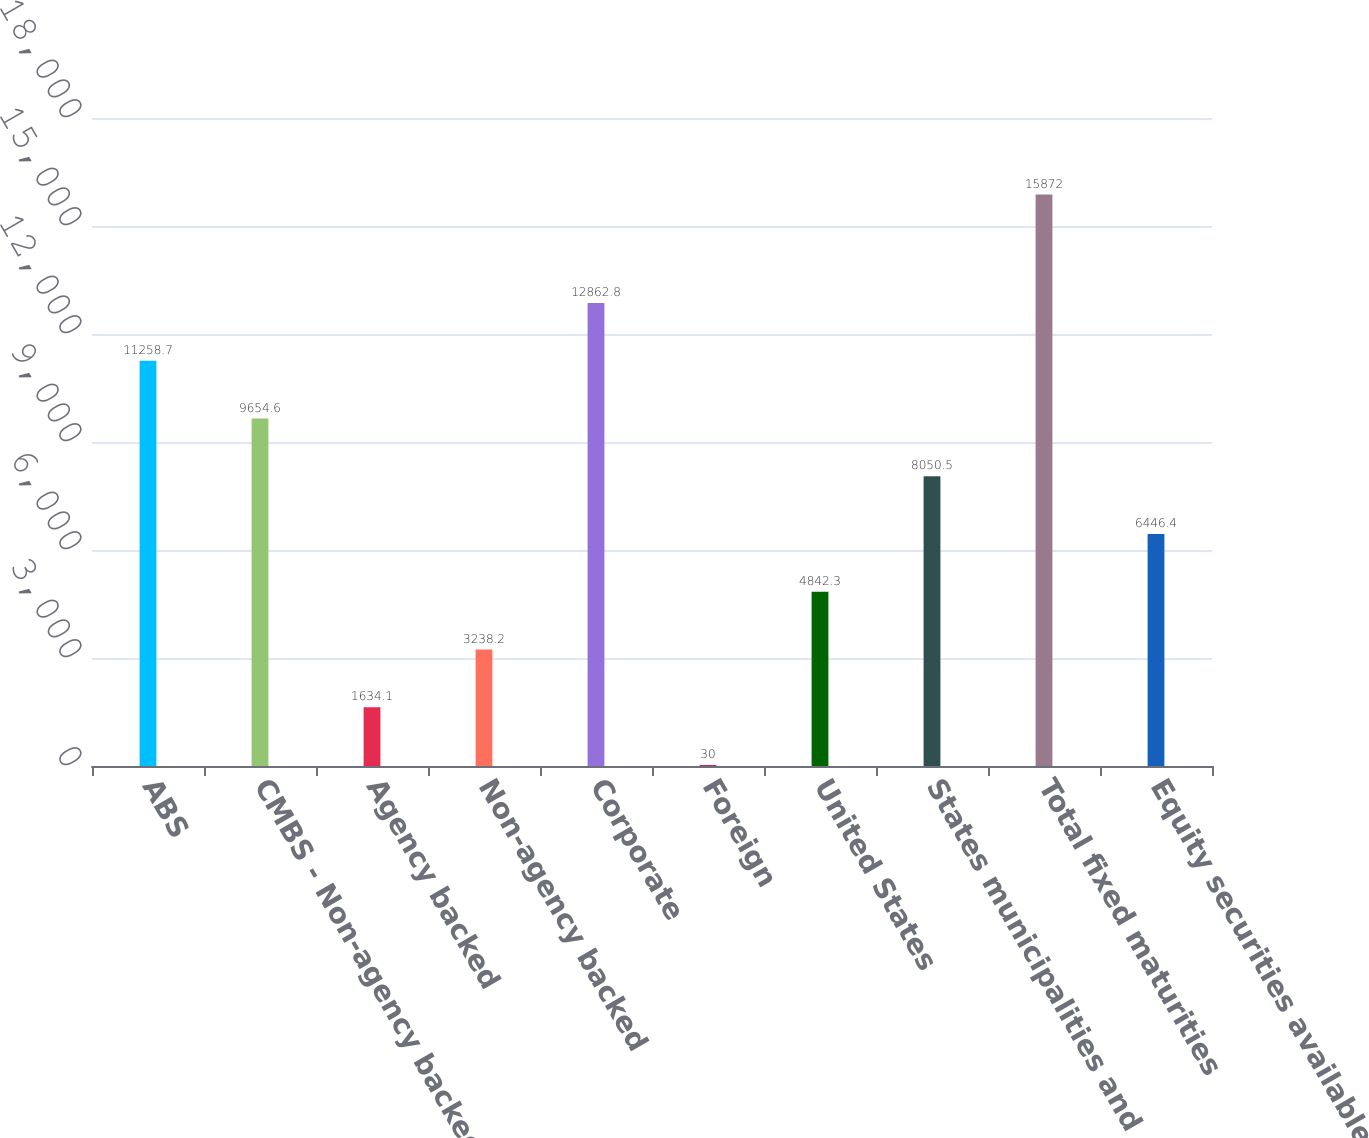<chart> <loc_0><loc_0><loc_500><loc_500><bar_chart><fcel>ABS<fcel>CMBS - Non-agency backed<fcel>Agency backed<fcel>Non-agency backed<fcel>Corporate<fcel>Foreign<fcel>United States<fcel>States municipalities and<fcel>Total fixed maturities<fcel>Equity securities available-<nl><fcel>11258.7<fcel>9654.6<fcel>1634.1<fcel>3238.2<fcel>12862.8<fcel>30<fcel>4842.3<fcel>8050.5<fcel>15872<fcel>6446.4<nl></chart> 